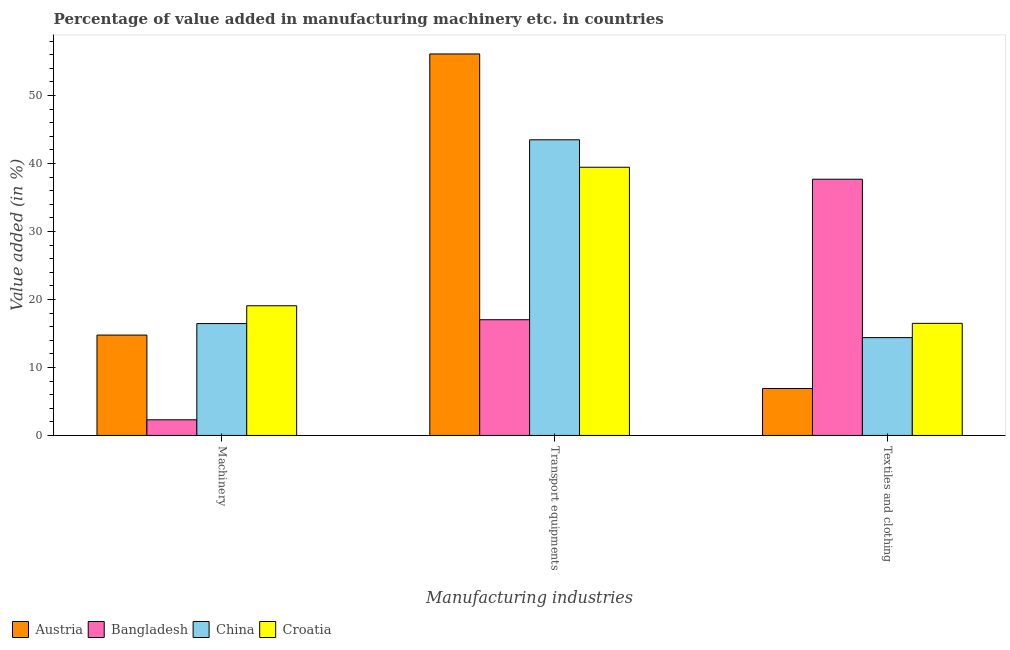How many groups of bars are there?
Ensure brevity in your answer.  3. Are the number of bars per tick equal to the number of legend labels?
Provide a short and direct response. Yes. How many bars are there on the 3rd tick from the left?
Your answer should be very brief. 4. How many bars are there on the 1st tick from the right?
Your answer should be compact. 4. What is the label of the 2nd group of bars from the left?
Your answer should be compact. Transport equipments. What is the value added in manufacturing textile and clothing in Bangladesh?
Provide a short and direct response. 37.69. Across all countries, what is the maximum value added in manufacturing transport equipments?
Keep it short and to the point. 56.11. Across all countries, what is the minimum value added in manufacturing machinery?
Offer a terse response. 2.3. What is the total value added in manufacturing textile and clothing in the graph?
Offer a very short reply. 75.47. What is the difference between the value added in manufacturing textile and clothing in Bangladesh and that in Croatia?
Make the answer very short. 21.2. What is the difference between the value added in manufacturing textile and clothing in China and the value added in manufacturing transport equipments in Bangladesh?
Provide a short and direct response. -2.63. What is the average value added in manufacturing textile and clothing per country?
Give a very brief answer. 18.87. What is the difference between the value added in manufacturing textile and clothing and value added in manufacturing machinery in Croatia?
Offer a very short reply. -2.59. What is the ratio of the value added in manufacturing transport equipments in Bangladesh to that in Austria?
Your response must be concise. 0.3. Is the value added in manufacturing machinery in Austria less than that in Croatia?
Make the answer very short. Yes. Is the difference between the value added in manufacturing machinery in Croatia and Austria greater than the difference between the value added in manufacturing transport equipments in Croatia and Austria?
Give a very brief answer. Yes. What is the difference between the highest and the second highest value added in manufacturing textile and clothing?
Make the answer very short. 21.2. What is the difference between the highest and the lowest value added in manufacturing machinery?
Provide a succinct answer. 16.78. In how many countries, is the value added in manufacturing machinery greater than the average value added in manufacturing machinery taken over all countries?
Your answer should be compact. 3. What does the 4th bar from the left in Textiles and clothing represents?
Make the answer very short. Croatia. Is it the case that in every country, the sum of the value added in manufacturing machinery and value added in manufacturing transport equipments is greater than the value added in manufacturing textile and clothing?
Keep it short and to the point. No. Are all the bars in the graph horizontal?
Your response must be concise. No. How many countries are there in the graph?
Provide a succinct answer. 4. Does the graph contain any zero values?
Your answer should be very brief. No. Does the graph contain grids?
Your response must be concise. No. How many legend labels are there?
Offer a very short reply. 4. What is the title of the graph?
Ensure brevity in your answer.  Percentage of value added in manufacturing machinery etc. in countries. What is the label or title of the X-axis?
Make the answer very short. Manufacturing industries. What is the label or title of the Y-axis?
Provide a short and direct response. Value added (in %). What is the Value added (in %) of Austria in Machinery?
Give a very brief answer. 14.76. What is the Value added (in %) in Bangladesh in Machinery?
Offer a very short reply. 2.3. What is the Value added (in %) in China in Machinery?
Give a very brief answer. 16.45. What is the Value added (in %) of Croatia in Machinery?
Your response must be concise. 19.08. What is the Value added (in %) of Austria in Transport equipments?
Your response must be concise. 56.11. What is the Value added (in %) of Bangladesh in Transport equipments?
Keep it short and to the point. 17.02. What is the Value added (in %) of China in Transport equipments?
Your answer should be compact. 43.49. What is the Value added (in %) in Croatia in Transport equipments?
Your response must be concise. 39.44. What is the Value added (in %) of Austria in Textiles and clothing?
Your response must be concise. 6.91. What is the Value added (in %) of Bangladesh in Textiles and clothing?
Offer a very short reply. 37.69. What is the Value added (in %) of China in Textiles and clothing?
Your answer should be very brief. 14.39. What is the Value added (in %) in Croatia in Textiles and clothing?
Offer a terse response. 16.49. Across all Manufacturing industries, what is the maximum Value added (in %) of Austria?
Provide a succinct answer. 56.11. Across all Manufacturing industries, what is the maximum Value added (in %) of Bangladesh?
Ensure brevity in your answer.  37.69. Across all Manufacturing industries, what is the maximum Value added (in %) in China?
Ensure brevity in your answer.  43.49. Across all Manufacturing industries, what is the maximum Value added (in %) of Croatia?
Provide a succinct answer. 39.44. Across all Manufacturing industries, what is the minimum Value added (in %) of Austria?
Your answer should be very brief. 6.91. Across all Manufacturing industries, what is the minimum Value added (in %) in Bangladesh?
Make the answer very short. 2.3. Across all Manufacturing industries, what is the minimum Value added (in %) of China?
Your answer should be compact. 14.39. Across all Manufacturing industries, what is the minimum Value added (in %) in Croatia?
Your answer should be compact. 16.49. What is the total Value added (in %) of Austria in the graph?
Your answer should be very brief. 77.78. What is the total Value added (in %) of Bangladesh in the graph?
Your answer should be compact. 57. What is the total Value added (in %) in China in the graph?
Give a very brief answer. 74.33. What is the total Value added (in %) of Croatia in the graph?
Ensure brevity in your answer.  75.01. What is the difference between the Value added (in %) in Austria in Machinery and that in Transport equipments?
Your answer should be compact. -41.35. What is the difference between the Value added (in %) of Bangladesh in Machinery and that in Transport equipments?
Provide a succinct answer. -14.72. What is the difference between the Value added (in %) of China in Machinery and that in Transport equipments?
Provide a succinct answer. -27.03. What is the difference between the Value added (in %) of Croatia in Machinery and that in Transport equipments?
Your answer should be compact. -20.37. What is the difference between the Value added (in %) in Austria in Machinery and that in Textiles and clothing?
Offer a very short reply. 7.86. What is the difference between the Value added (in %) of Bangladesh in Machinery and that in Textiles and clothing?
Your answer should be compact. -35.39. What is the difference between the Value added (in %) in China in Machinery and that in Textiles and clothing?
Your response must be concise. 2.07. What is the difference between the Value added (in %) in Croatia in Machinery and that in Textiles and clothing?
Provide a short and direct response. 2.59. What is the difference between the Value added (in %) in Austria in Transport equipments and that in Textiles and clothing?
Your answer should be compact. 49.2. What is the difference between the Value added (in %) in Bangladesh in Transport equipments and that in Textiles and clothing?
Your answer should be compact. -20.67. What is the difference between the Value added (in %) in China in Transport equipments and that in Textiles and clothing?
Give a very brief answer. 29.1. What is the difference between the Value added (in %) in Croatia in Transport equipments and that in Textiles and clothing?
Give a very brief answer. 22.96. What is the difference between the Value added (in %) in Austria in Machinery and the Value added (in %) in Bangladesh in Transport equipments?
Provide a succinct answer. -2.26. What is the difference between the Value added (in %) of Austria in Machinery and the Value added (in %) of China in Transport equipments?
Provide a succinct answer. -28.72. What is the difference between the Value added (in %) of Austria in Machinery and the Value added (in %) of Croatia in Transport equipments?
Give a very brief answer. -24.68. What is the difference between the Value added (in %) of Bangladesh in Machinery and the Value added (in %) of China in Transport equipments?
Provide a short and direct response. -41.19. What is the difference between the Value added (in %) of Bangladesh in Machinery and the Value added (in %) of Croatia in Transport equipments?
Give a very brief answer. -37.15. What is the difference between the Value added (in %) in China in Machinery and the Value added (in %) in Croatia in Transport equipments?
Offer a very short reply. -22.99. What is the difference between the Value added (in %) in Austria in Machinery and the Value added (in %) in Bangladesh in Textiles and clothing?
Provide a short and direct response. -22.92. What is the difference between the Value added (in %) in Austria in Machinery and the Value added (in %) in China in Textiles and clothing?
Ensure brevity in your answer.  0.37. What is the difference between the Value added (in %) of Austria in Machinery and the Value added (in %) of Croatia in Textiles and clothing?
Give a very brief answer. -1.73. What is the difference between the Value added (in %) in Bangladesh in Machinery and the Value added (in %) in China in Textiles and clothing?
Offer a very short reply. -12.09. What is the difference between the Value added (in %) of Bangladesh in Machinery and the Value added (in %) of Croatia in Textiles and clothing?
Keep it short and to the point. -14.19. What is the difference between the Value added (in %) in China in Machinery and the Value added (in %) in Croatia in Textiles and clothing?
Offer a very short reply. -0.03. What is the difference between the Value added (in %) of Austria in Transport equipments and the Value added (in %) of Bangladesh in Textiles and clothing?
Ensure brevity in your answer.  18.43. What is the difference between the Value added (in %) of Austria in Transport equipments and the Value added (in %) of China in Textiles and clothing?
Offer a very short reply. 41.72. What is the difference between the Value added (in %) in Austria in Transport equipments and the Value added (in %) in Croatia in Textiles and clothing?
Give a very brief answer. 39.62. What is the difference between the Value added (in %) of Bangladesh in Transport equipments and the Value added (in %) of China in Textiles and clothing?
Offer a very short reply. 2.63. What is the difference between the Value added (in %) of Bangladesh in Transport equipments and the Value added (in %) of Croatia in Textiles and clothing?
Your answer should be very brief. 0.53. What is the difference between the Value added (in %) of China in Transport equipments and the Value added (in %) of Croatia in Textiles and clothing?
Your answer should be compact. 27. What is the average Value added (in %) of Austria per Manufacturing industries?
Offer a very short reply. 25.93. What is the average Value added (in %) of Bangladesh per Manufacturing industries?
Your answer should be very brief. 19. What is the average Value added (in %) of China per Manufacturing industries?
Provide a short and direct response. 24.78. What is the average Value added (in %) in Croatia per Manufacturing industries?
Give a very brief answer. 25. What is the difference between the Value added (in %) of Austria and Value added (in %) of Bangladesh in Machinery?
Your answer should be compact. 12.46. What is the difference between the Value added (in %) in Austria and Value added (in %) in China in Machinery?
Make the answer very short. -1.69. What is the difference between the Value added (in %) in Austria and Value added (in %) in Croatia in Machinery?
Provide a short and direct response. -4.31. What is the difference between the Value added (in %) in Bangladesh and Value added (in %) in China in Machinery?
Provide a short and direct response. -14.15. What is the difference between the Value added (in %) in Bangladesh and Value added (in %) in Croatia in Machinery?
Offer a terse response. -16.78. What is the difference between the Value added (in %) of China and Value added (in %) of Croatia in Machinery?
Offer a terse response. -2.62. What is the difference between the Value added (in %) of Austria and Value added (in %) of Bangladesh in Transport equipments?
Offer a terse response. 39.09. What is the difference between the Value added (in %) of Austria and Value added (in %) of China in Transport equipments?
Keep it short and to the point. 12.63. What is the difference between the Value added (in %) in Austria and Value added (in %) in Croatia in Transport equipments?
Provide a short and direct response. 16.67. What is the difference between the Value added (in %) of Bangladesh and Value added (in %) of China in Transport equipments?
Give a very brief answer. -26.47. What is the difference between the Value added (in %) of Bangladesh and Value added (in %) of Croatia in Transport equipments?
Ensure brevity in your answer.  -22.43. What is the difference between the Value added (in %) in China and Value added (in %) in Croatia in Transport equipments?
Your answer should be compact. 4.04. What is the difference between the Value added (in %) in Austria and Value added (in %) in Bangladesh in Textiles and clothing?
Your response must be concise. -30.78. What is the difference between the Value added (in %) of Austria and Value added (in %) of China in Textiles and clothing?
Your response must be concise. -7.48. What is the difference between the Value added (in %) of Austria and Value added (in %) of Croatia in Textiles and clothing?
Give a very brief answer. -9.58. What is the difference between the Value added (in %) of Bangladesh and Value added (in %) of China in Textiles and clothing?
Make the answer very short. 23.3. What is the difference between the Value added (in %) of Bangladesh and Value added (in %) of Croatia in Textiles and clothing?
Keep it short and to the point. 21.2. What is the difference between the Value added (in %) of China and Value added (in %) of Croatia in Textiles and clothing?
Offer a terse response. -2.1. What is the ratio of the Value added (in %) of Austria in Machinery to that in Transport equipments?
Keep it short and to the point. 0.26. What is the ratio of the Value added (in %) in Bangladesh in Machinery to that in Transport equipments?
Give a very brief answer. 0.14. What is the ratio of the Value added (in %) in China in Machinery to that in Transport equipments?
Your answer should be compact. 0.38. What is the ratio of the Value added (in %) of Croatia in Machinery to that in Transport equipments?
Your answer should be very brief. 0.48. What is the ratio of the Value added (in %) in Austria in Machinery to that in Textiles and clothing?
Ensure brevity in your answer.  2.14. What is the ratio of the Value added (in %) of Bangladesh in Machinery to that in Textiles and clothing?
Provide a short and direct response. 0.06. What is the ratio of the Value added (in %) in China in Machinery to that in Textiles and clothing?
Your answer should be compact. 1.14. What is the ratio of the Value added (in %) in Croatia in Machinery to that in Textiles and clothing?
Keep it short and to the point. 1.16. What is the ratio of the Value added (in %) in Austria in Transport equipments to that in Textiles and clothing?
Provide a succinct answer. 8.12. What is the ratio of the Value added (in %) in Bangladesh in Transport equipments to that in Textiles and clothing?
Offer a terse response. 0.45. What is the ratio of the Value added (in %) of China in Transport equipments to that in Textiles and clothing?
Give a very brief answer. 3.02. What is the ratio of the Value added (in %) in Croatia in Transport equipments to that in Textiles and clothing?
Your answer should be compact. 2.39. What is the difference between the highest and the second highest Value added (in %) of Austria?
Your answer should be compact. 41.35. What is the difference between the highest and the second highest Value added (in %) in Bangladesh?
Your response must be concise. 20.67. What is the difference between the highest and the second highest Value added (in %) in China?
Give a very brief answer. 27.03. What is the difference between the highest and the second highest Value added (in %) in Croatia?
Ensure brevity in your answer.  20.37. What is the difference between the highest and the lowest Value added (in %) in Austria?
Your answer should be compact. 49.2. What is the difference between the highest and the lowest Value added (in %) of Bangladesh?
Ensure brevity in your answer.  35.39. What is the difference between the highest and the lowest Value added (in %) of China?
Keep it short and to the point. 29.1. What is the difference between the highest and the lowest Value added (in %) in Croatia?
Offer a very short reply. 22.96. 